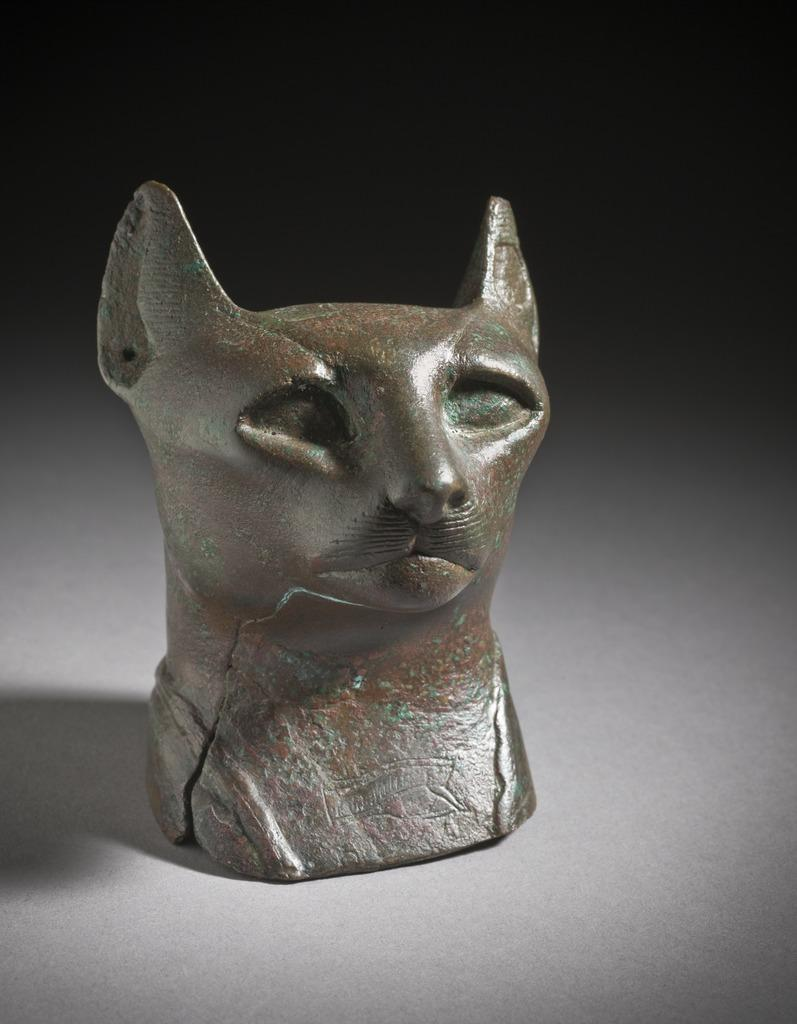What is the main subject of the image? There is a statue in the image. What is the statue a representation of? The statue is of a cat head. Where is the statue located in the image? The statue is on the floor. How many roses are surrounding the cat head statue in the image? There are no roses present in the image; it only features a cat head statue on the floor. 